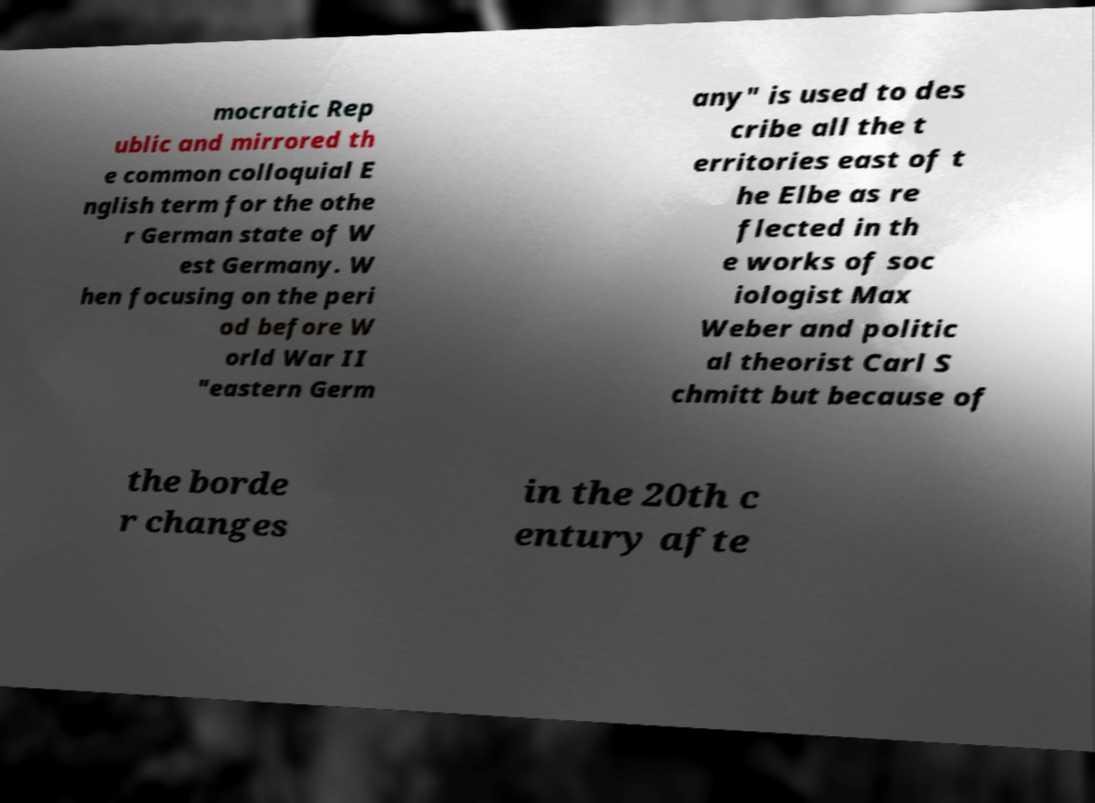Could you extract and type out the text from this image? mocratic Rep ublic and mirrored th e common colloquial E nglish term for the othe r German state of W est Germany. W hen focusing on the peri od before W orld War II "eastern Germ any" is used to des cribe all the t erritories east of t he Elbe as re flected in th e works of soc iologist Max Weber and politic al theorist Carl S chmitt but because of the borde r changes in the 20th c entury afte 